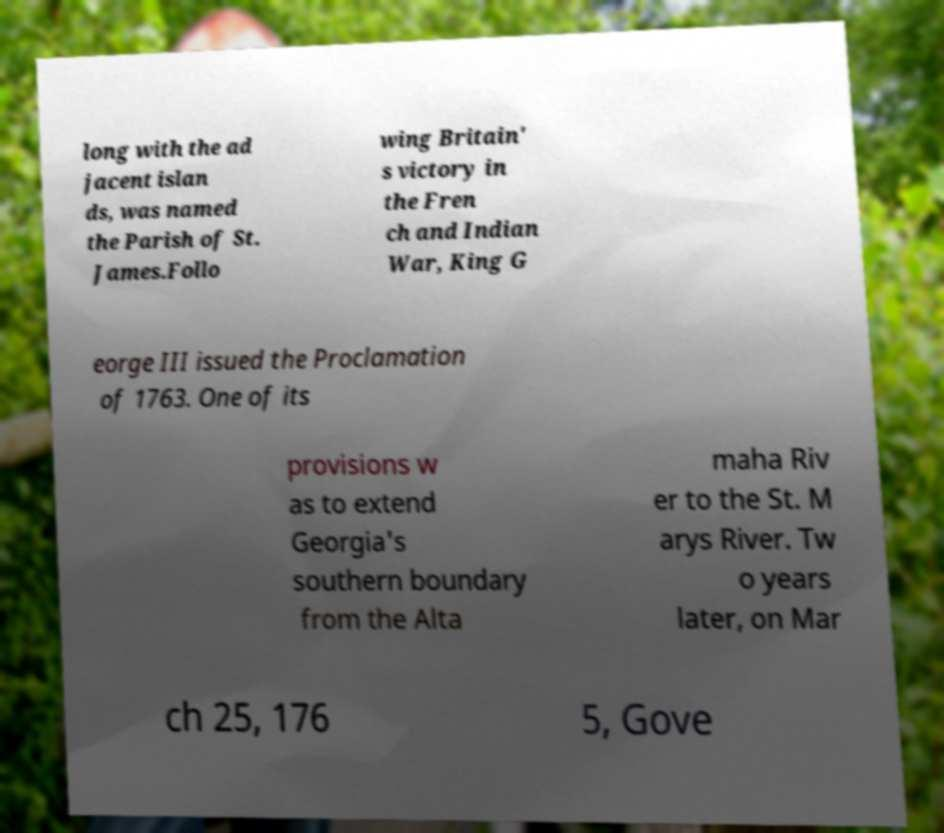For documentation purposes, I need the text within this image transcribed. Could you provide that? long with the ad jacent islan ds, was named the Parish of St. James.Follo wing Britain' s victory in the Fren ch and Indian War, King G eorge III issued the Proclamation of 1763. One of its provisions w as to extend Georgia's southern boundary from the Alta maha Riv er to the St. M arys River. Tw o years later, on Mar ch 25, 176 5, Gove 